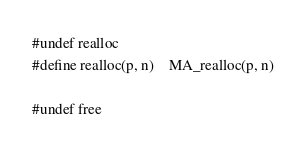Convert code to text. <code><loc_0><loc_0><loc_500><loc_500><_C_>
#undef realloc
#define realloc(p, n)	MA_realloc(p, n)

#undef free</code> 